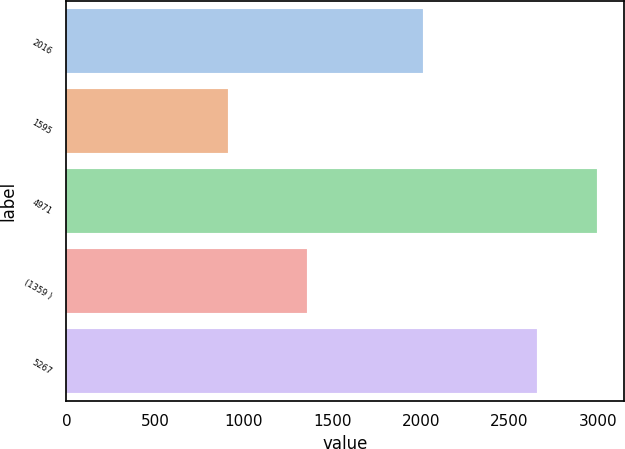<chart> <loc_0><loc_0><loc_500><loc_500><bar_chart><fcel>2016<fcel>1595<fcel>4971<fcel>(1359 )<fcel>5267<nl><fcel>2015<fcel>914<fcel>2995<fcel>1359<fcel>2656<nl></chart> 